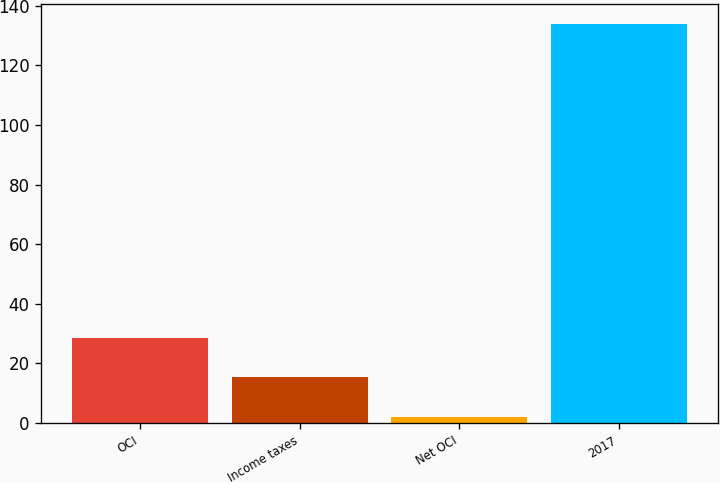<chart> <loc_0><loc_0><loc_500><loc_500><bar_chart><fcel>OCI<fcel>Income taxes<fcel>Net OCI<fcel>2017<nl><fcel>28.4<fcel>15.2<fcel>2<fcel>134<nl></chart> 